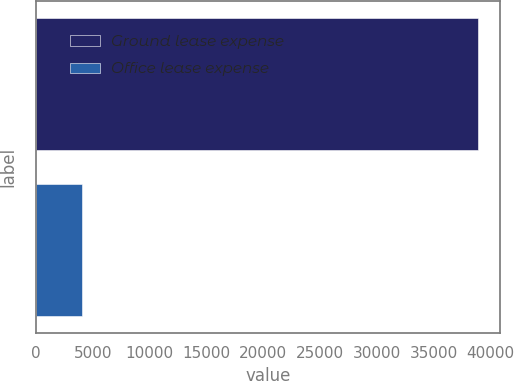Convert chart to OTSL. <chart><loc_0><loc_0><loc_500><loc_500><bar_chart><fcel>Ground lease expense<fcel>Office lease expense<nl><fcel>38851<fcel>4067<nl></chart> 